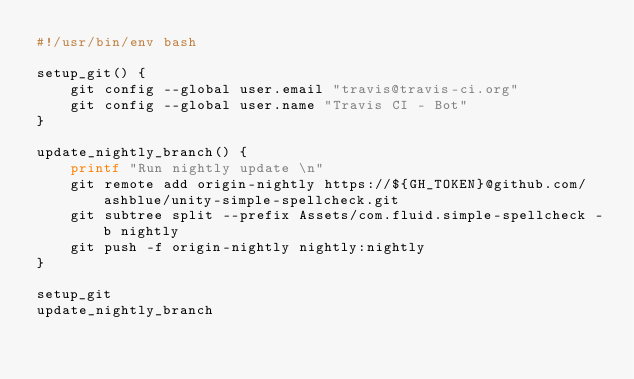Convert code to text. <code><loc_0><loc_0><loc_500><loc_500><_Bash_>#!/usr/bin/env bash

setup_git() {
    git config --global user.email "travis@travis-ci.org"
    git config --global user.name "Travis CI - Bot"
}

update_nightly_branch() {
    printf "Run nightly update \n"
    git remote add origin-nightly https://${GH_TOKEN}@github.com/ashblue/unity-simple-spellcheck.git
    git subtree split --prefix Assets/com.fluid.simple-spellcheck -b nightly
    git push -f origin-nightly nightly:nightly
}

setup_git
update_nightly_branch
</code> 